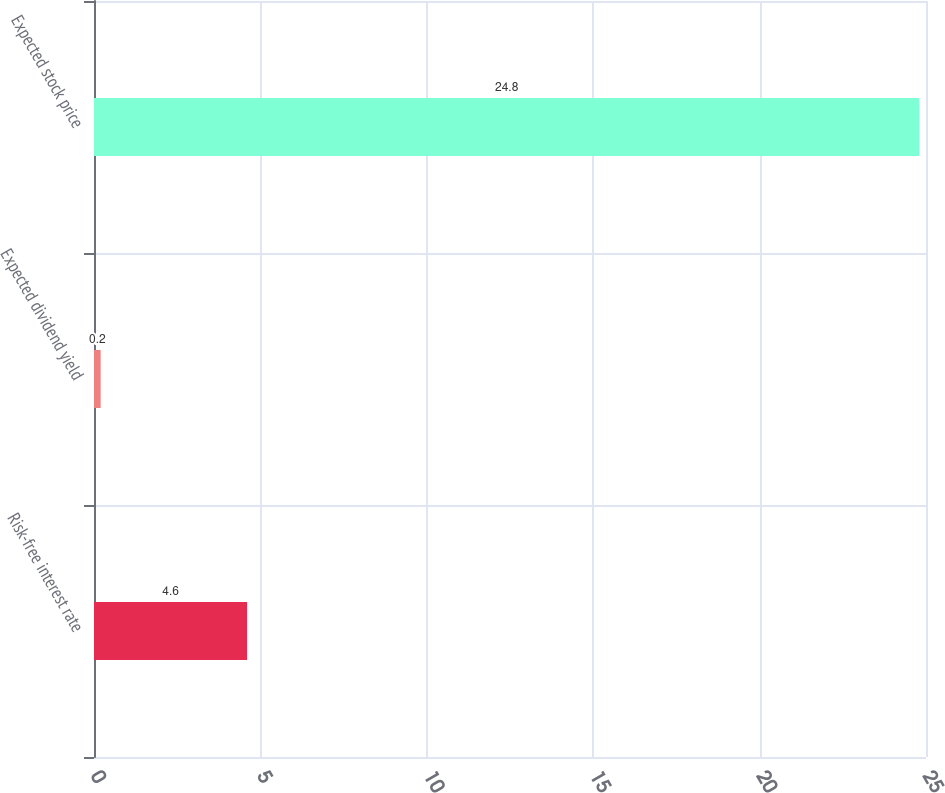Convert chart to OTSL. <chart><loc_0><loc_0><loc_500><loc_500><bar_chart><fcel>Risk-free interest rate<fcel>Expected dividend yield<fcel>Expected stock price<nl><fcel>4.6<fcel>0.2<fcel>24.8<nl></chart> 